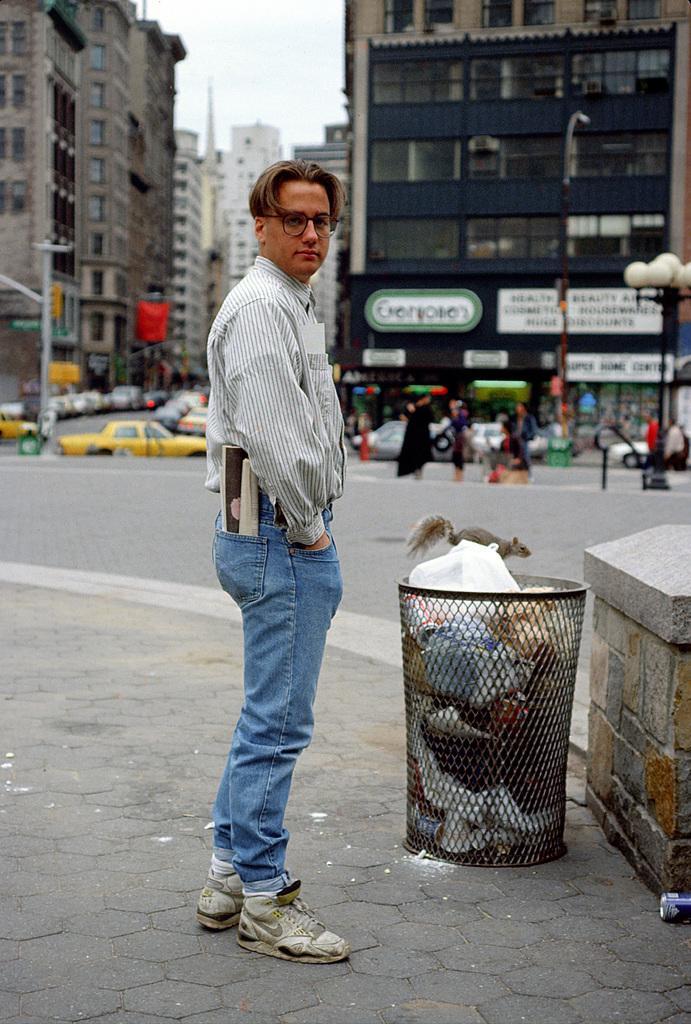Please provide a concise description of this image. In this image we can see a person standing on the footpath beside a dustbin. On the backside we can see a squirrel on the road. We can also see a group of buildings with windows, some poles, vehicles, a street lamp, a group of people on the road and the sky which looks cloudy. 